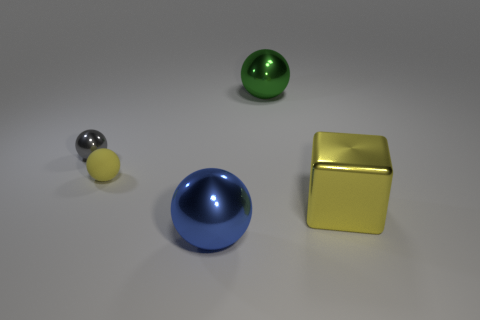Subtract all green blocks. Subtract all green cylinders. How many blocks are left? 1 Add 4 big purple matte blocks. How many objects exist? 9 Subtract all blocks. How many objects are left? 4 Add 5 large blue metal objects. How many large blue metal objects exist? 6 Subtract 0 yellow cylinders. How many objects are left? 5 Subtract all objects. Subtract all big yellow metal cylinders. How many objects are left? 0 Add 5 green metallic balls. How many green metallic balls are left? 6 